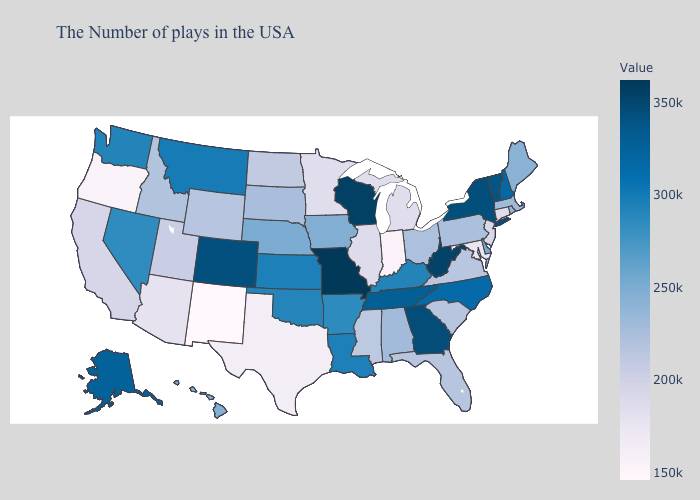Among the states that border Maryland , which have the lowest value?
Quick response, please. Virginia. Does Missouri have the lowest value in the USA?
Answer briefly. No. Does North Carolina have a lower value than West Virginia?
Quick response, please. Yes. Which states have the highest value in the USA?
Give a very brief answer. Missouri. 